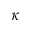Convert formula to latex. <formula><loc_0><loc_0><loc_500><loc_500>\kappa</formula> 